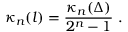Convert formula to latex. <formula><loc_0><loc_0><loc_500><loc_500>\kappa _ { n } ( l ) = \frac { \kappa _ { n } ( \Delta ) } { 2 ^ { n } - 1 } \ .</formula> 